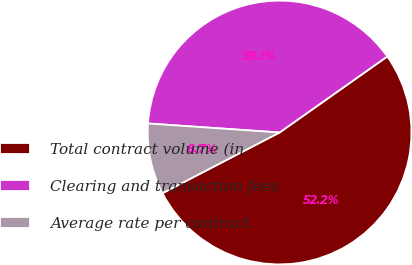Convert chart to OTSL. <chart><loc_0><loc_0><loc_500><loc_500><pie_chart><fcel>Total contract volume (in<fcel>Clearing and transaction fees<fcel>Average rate per contract<nl><fcel>52.17%<fcel>39.13%<fcel>8.7%<nl></chart> 